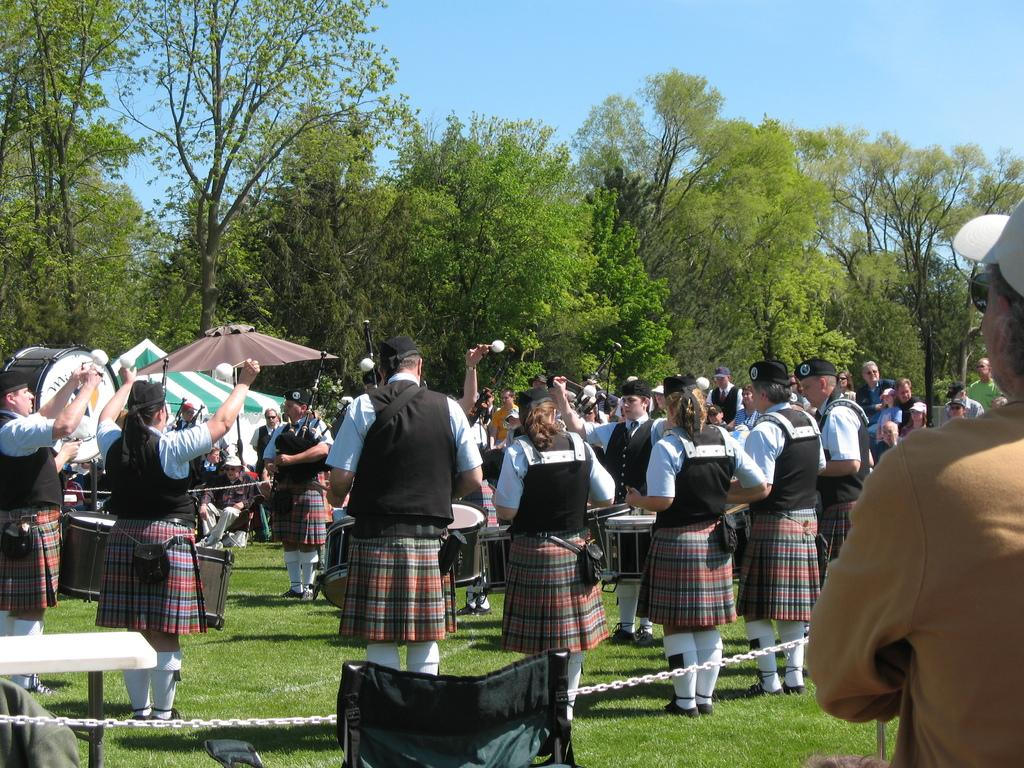What can be seen in the image involving people? There are people standing in the image. What object is present that might be used for eating or gathering? There is a table in the image. What type of natural environment is visible in the image? There is grass and trees in the image. What object might be used for protection from the sun or rain? There is an umbrella in the image. What type of material or object is present that might be used for restraining or connecting? There is a chain in the image. What color is the silver van in the image? There is no silver van present in the image. How many attempts were made to climb the tree in the image? There is no indication of anyone attempting to climb a tree in the image. 